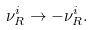Convert formula to latex. <formula><loc_0><loc_0><loc_500><loc_500>\nu _ { R } ^ { i } \to - \nu _ { R } ^ { i } .</formula> 